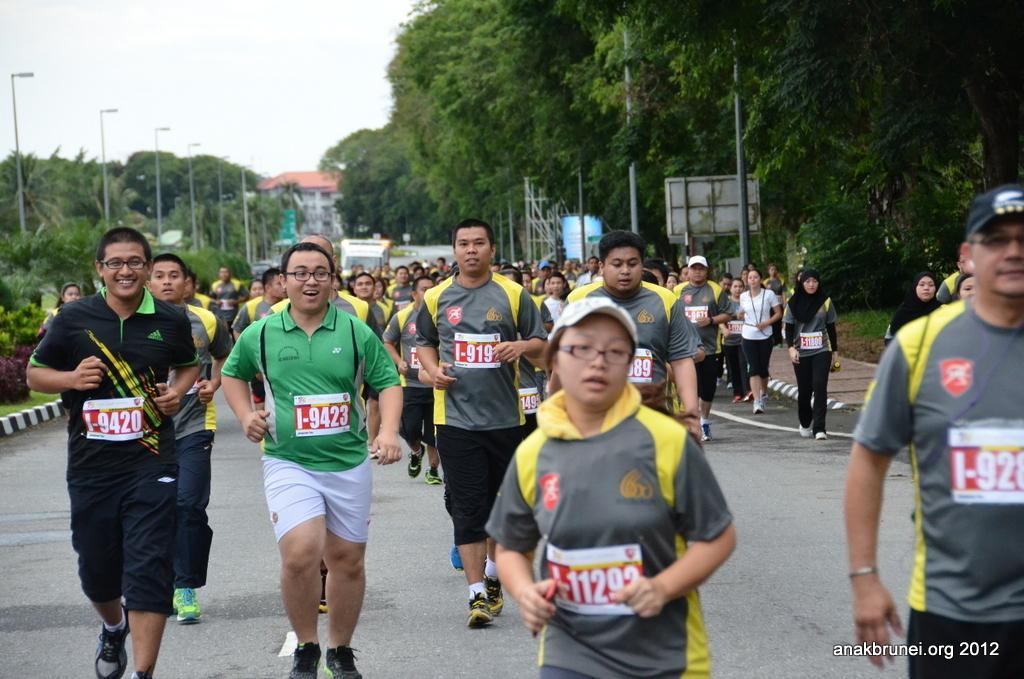In one or two sentences, can you explain what this image depicts? In this picture we can see a group of people running on the road, poles, trees, building and in the background we can see the sky. 